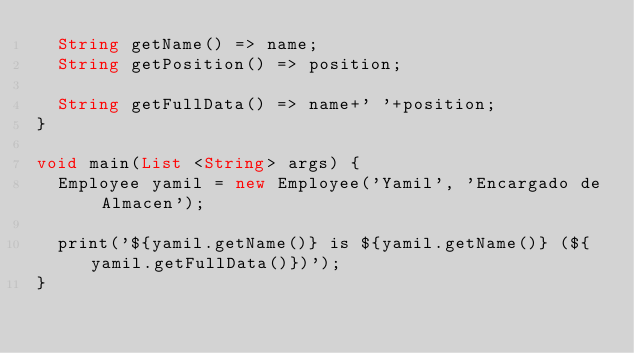<code> <loc_0><loc_0><loc_500><loc_500><_Dart_>  String getName() => name;
  String getPosition() => position;

  String getFullData() => name+' '+position;
}

void main(List <String> args) {
  Employee yamil = new Employee('Yamil', 'Encargado de Almacen');

  print('${yamil.getName()} is ${yamil.getName()} (${yamil.getFullData()})');
}</code> 